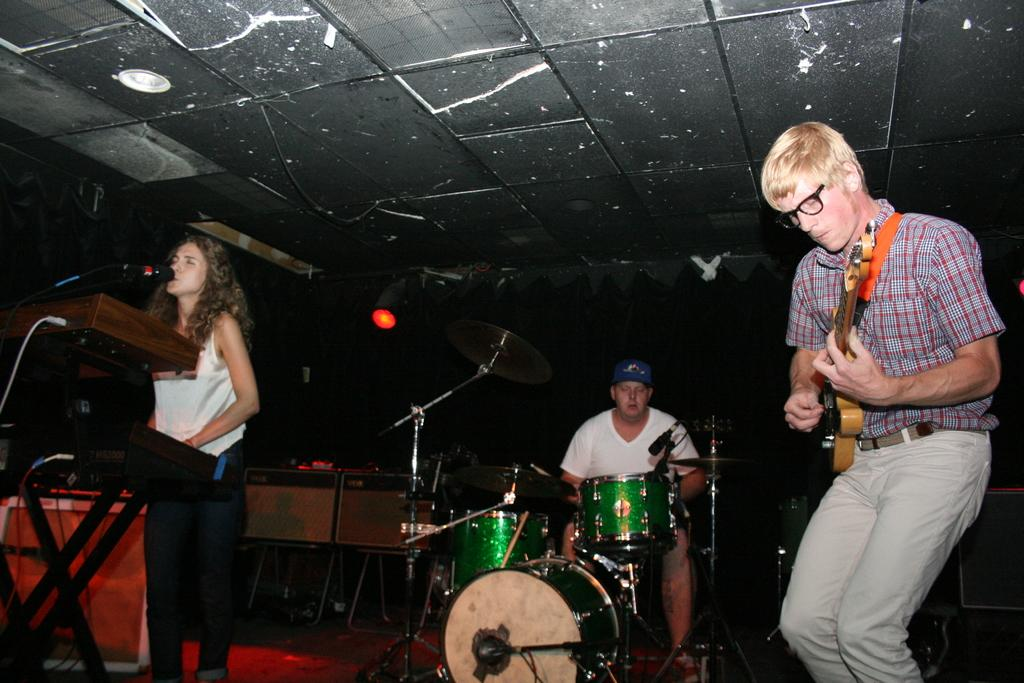How many people are in the image? There are three people in the image. Can you describe the gender of each person? Two of them are men, and one of them is a woman. What are the people in the image doing? All three people are playing musical instruments. What type of spot can be seen on the woman's dress in the image? There is no spot visible on the woman's dress in the image. What type of rice is being cooked in the background of the image? There is no rice or cooking activity present in the image. 